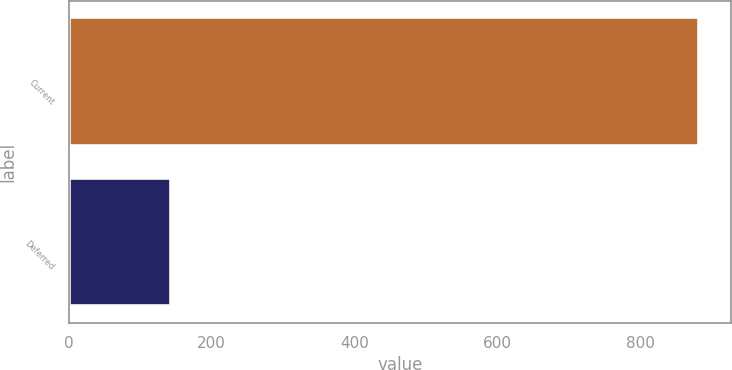Convert chart. <chart><loc_0><loc_0><loc_500><loc_500><bar_chart><fcel>Current<fcel>Deferred<nl><fcel>883<fcel>143<nl></chart> 